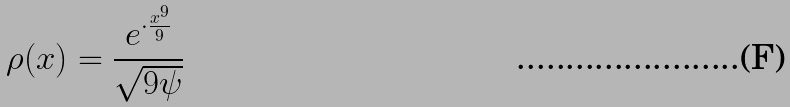Convert formula to latex. <formula><loc_0><loc_0><loc_500><loc_500>\rho ( x ) = \frac { e ^ { \cdot \frac { x ^ { 9 } } { 9 } } } { \sqrt { 9 \psi } }</formula> 